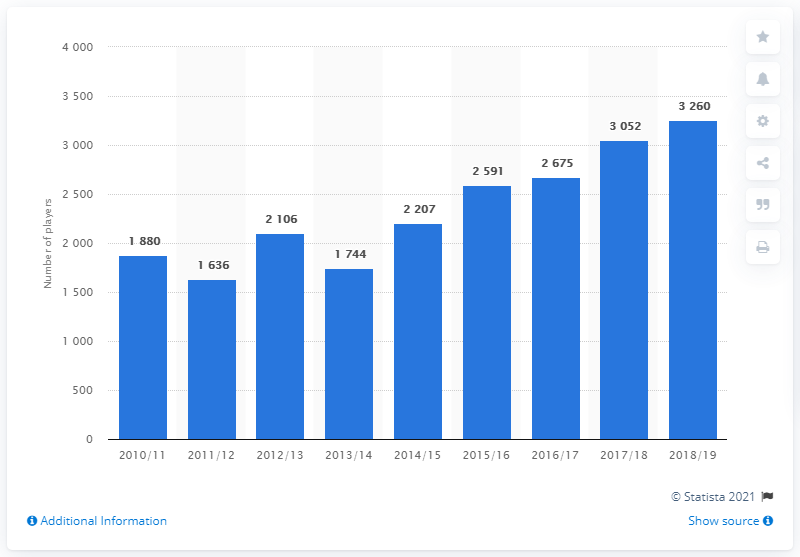Draw attention to some important aspects in this diagram. The number of players in the 2018/19 season was 3,260. The number of players in the year 2017/18 was not greater than the number of players in the year 2018/19. 